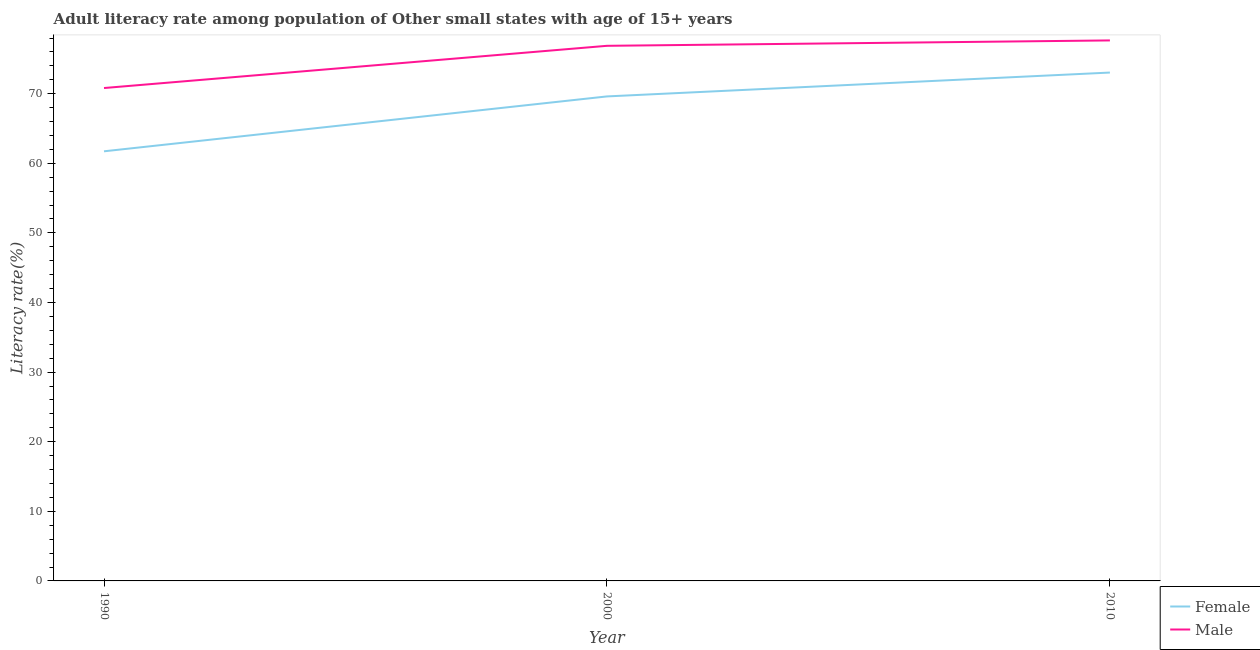Does the line corresponding to male adult literacy rate intersect with the line corresponding to female adult literacy rate?
Keep it short and to the point. No. What is the male adult literacy rate in 2010?
Provide a succinct answer. 77.66. Across all years, what is the maximum male adult literacy rate?
Offer a very short reply. 77.66. Across all years, what is the minimum female adult literacy rate?
Ensure brevity in your answer.  61.73. In which year was the male adult literacy rate maximum?
Your answer should be very brief. 2010. In which year was the male adult literacy rate minimum?
Your response must be concise. 1990. What is the total male adult literacy rate in the graph?
Keep it short and to the point. 225.36. What is the difference between the male adult literacy rate in 1990 and that in 2010?
Offer a very short reply. -6.84. What is the difference between the female adult literacy rate in 2010 and the male adult literacy rate in 2000?
Your answer should be very brief. -3.84. What is the average male adult literacy rate per year?
Make the answer very short. 75.12. In the year 1990, what is the difference between the female adult literacy rate and male adult literacy rate?
Keep it short and to the point. -9.09. In how many years, is the male adult literacy rate greater than 8 %?
Your response must be concise. 3. What is the ratio of the male adult literacy rate in 1990 to that in 2000?
Provide a succinct answer. 0.92. Is the male adult literacy rate in 1990 less than that in 2000?
Ensure brevity in your answer.  Yes. Is the difference between the male adult literacy rate in 1990 and 2010 greater than the difference between the female adult literacy rate in 1990 and 2010?
Your answer should be very brief. Yes. What is the difference between the highest and the second highest female adult literacy rate?
Your response must be concise. 3.43. What is the difference between the highest and the lowest female adult literacy rate?
Offer a very short reply. 11.31. Is the female adult literacy rate strictly less than the male adult literacy rate over the years?
Make the answer very short. Yes. What is the difference between two consecutive major ticks on the Y-axis?
Offer a terse response. 10. Does the graph contain grids?
Make the answer very short. No. How many legend labels are there?
Offer a terse response. 2. What is the title of the graph?
Make the answer very short. Adult literacy rate among population of Other small states with age of 15+ years. What is the label or title of the X-axis?
Make the answer very short. Year. What is the label or title of the Y-axis?
Your answer should be compact. Literacy rate(%). What is the Literacy rate(%) in Female in 1990?
Provide a short and direct response. 61.73. What is the Literacy rate(%) in Male in 1990?
Your answer should be compact. 70.82. What is the Literacy rate(%) of Female in 2000?
Keep it short and to the point. 69.61. What is the Literacy rate(%) of Male in 2000?
Your answer should be very brief. 76.88. What is the Literacy rate(%) of Female in 2010?
Make the answer very short. 73.04. What is the Literacy rate(%) in Male in 2010?
Offer a very short reply. 77.66. Across all years, what is the maximum Literacy rate(%) of Female?
Your answer should be compact. 73.04. Across all years, what is the maximum Literacy rate(%) of Male?
Give a very brief answer. 77.66. Across all years, what is the minimum Literacy rate(%) of Female?
Offer a very short reply. 61.73. Across all years, what is the minimum Literacy rate(%) of Male?
Your answer should be very brief. 70.82. What is the total Literacy rate(%) in Female in the graph?
Provide a short and direct response. 204.38. What is the total Literacy rate(%) of Male in the graph?
Keep it short and to the point. 225.36. What is the difference between the Literacy rate(%) of Female in 1990 and that in 2000?
Offer a very short reply. -7.89. What is the difference between the Literacy rate(%) of Male in 1990 and that in 2000?
Give a very brief answer. -6.07. What is the difference between the Literacy rate(%) of Female in 1990 and that in 2010?
Make the answer very short. -11.31. What is the difference between the Literacy rate(%) of Male in 1990 and that in 2010?
Your response must be concise. -6.84. What is the difference between the Literacy rate(%) of Female in 2000 and that in 2010?
Keep it short and to the point. -3.43. What is the difference between the Literacy rate(%) of Male in 2000 and that in 2010?
Make the answer very short. -0.78. What is the difference between the Literacy rate(%) of Female in 1990 and the Literacy rate(%) of Male in 2000?
Offer a terse response. -15.16. What is the difference between the Literacy rate(%) in Female in 1990 and the Literacy rate(%) in Male in 2010?
Offer a very short reply. -15.93. What is the difference between the Literacy rate(%) in Female in 2000 and the Literacy rate(%) in Male in 2010?
Make the answer very short. -8.05. What is the average Literacy rate(%) in Female per year?
Ensure brevity in your answer.  68.13. What is the average Literacy rate(%) of Male per year?
Make the answer very short. 75.12. In the year 1990, what is the difference between the Literacy rate(%) of Female and Literacy rate(%) of Male?
Offer a very short reply. -9.09. In the year 2000, what is the difference between the Literacy rate(%) of Female and Literacy rate(%) of Male?
Give a very brief answer. -7.27. In the year 2010, what is the difference between the Literacy rate(%) of Female and Literacy rate(%) of Male?
Provide a short and direct response. -4.62. What is the ratio of the Literacy rate(%) of Female in 1990 to that in 2000?
Give a very brief answer. 0.89. What is the ratio of the Literacy rate(%) of Male in 1990 to that in 2000?
Provide a succinct answer. 0.92. What is the ratio of the Literacy rate(%) in Female in 1990 to that in 2010?
Make the answer very short. 0.85. What is the ratio of the Literacy rate(%) in Male in 1990 to that in 2010?
Your answer should be compact. 0.91. What is the ratio of the Literacy rate(%) in Female in 2000 to that in 2010?
Your response must be concise. 0.95. What is the ratio of the Literacy rate(%) in Male in 2000 to that in 2010?
Ensure brevity in your answer.  0.99. What is the difference between the highest and the second highest Literacy rate(%) of Female?
Offer a very short reply. 3.43. What is the difference between the highest and the second highest Literacy rate(%) of Male?
Offer a very short reply. 0.78. What is the difference between the highest and the lowest Literacy rate(%) in Female?
Provide a short and direct response. 11.31. What is the difference between the highest and the lowest Literacy rate(%) of Male?
Your answer should be very brief. 6.84. 